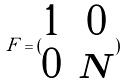Convert formula to latex. <formula><loc_0><loc_0><loc_500><loc_500>F = ( \begin{matrix} 1 & 0 \\ 0 & N \end{matrix} )</formula> 